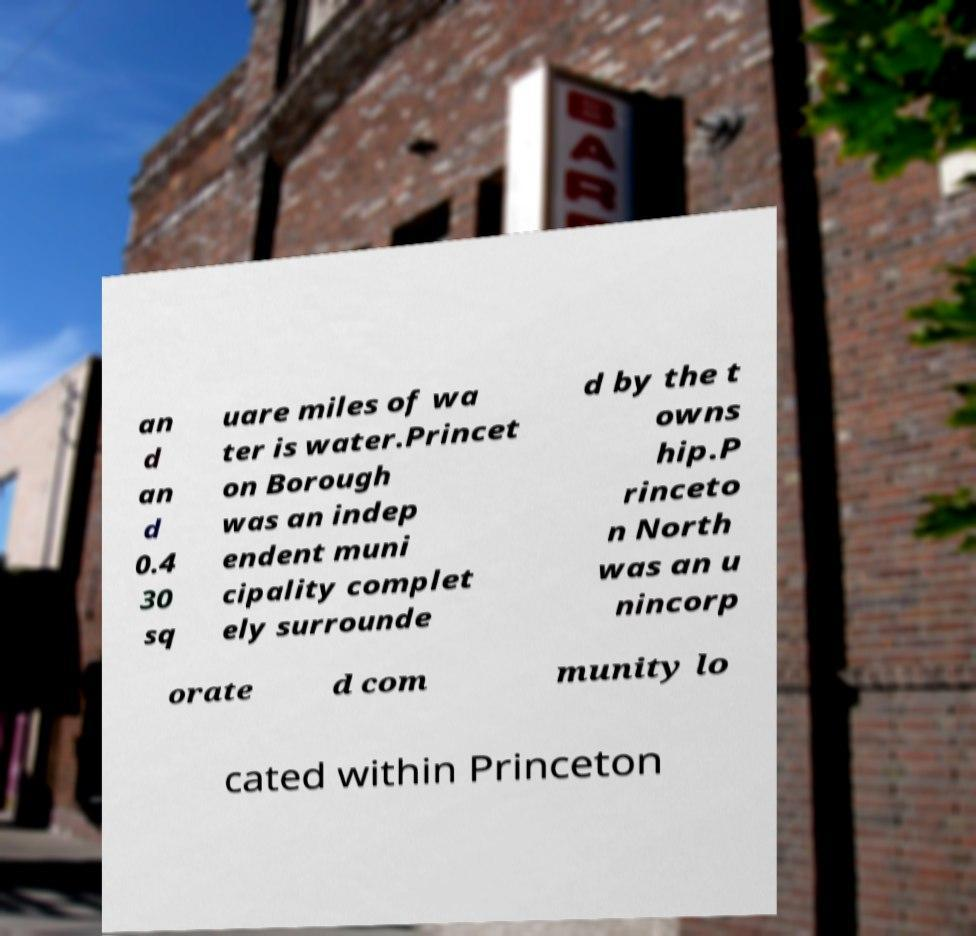Please identify and transcribe the text found in this image. an d an d 0.4 30 sq uare miles of wa ter is water.Princet on Borough was an indep endent muni cipality complet ely surrounde d by the t owns hip.P rinceto n North was an u nincorp orate d com munity lo cated within Princeton 